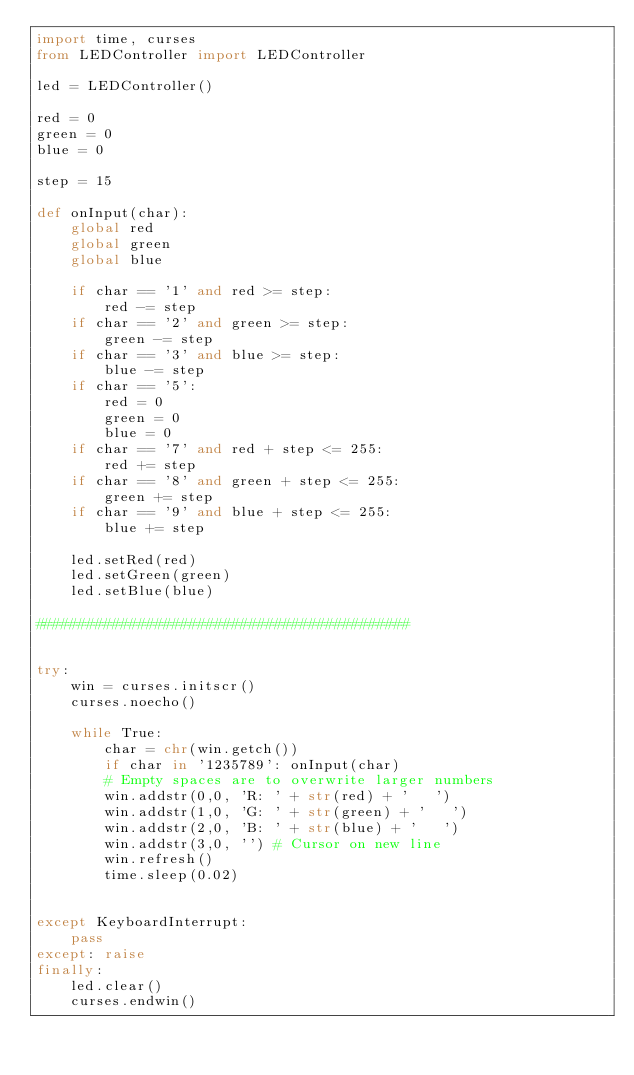<code> <loc_0><loc_0><loc_500><loc_500><_Python_>import time, curses
from LEDController import LEDController

led = LEDController()

red = 0
green = 0
blue = 0

step = 15

def onInput(char):
    global red
    global green
    global blue

    if char == '1' and red >= step:
        red -= step 
    if char == '2' and green >= step:
        green -= step
    if char == '3' and blue >= step:
        blue -= step
    if char == '5':
        red = 0
        green = 0
        blue = 0
    if char == '7' and red + step <= 255:
        red += step
    if char == '8' and green + step <= 255:
        green += step
    if char == '9' and blue + step <= 255:
        blue += step

    led.setRed(red)
    led.setGreen(green)
    led.setBlue(blue)

############################################


try:
    win = curses.initscr()
    curses.noecho()

    while True:
        char = chr(win.getch())
        if char in '1235789': onInput(char)
        # Empty spaces are to overwrite larger numbers
        win.addstr(0,0, 'R: ' + str(red) + '   ')
        win.addstr(1,0, 'G: ' + str(green) + '   ')
        win.addstr(2,0, 'B: ' + str(blue) + '   ')
        win.addstr(3,0, '') # Cursor on new line
        win.refresh()
        time.sleep(0.02)


except KeyboardInterrupt:
    pass
except: raise
finally:
    led.clear()
    curses.endwin()
</code> 